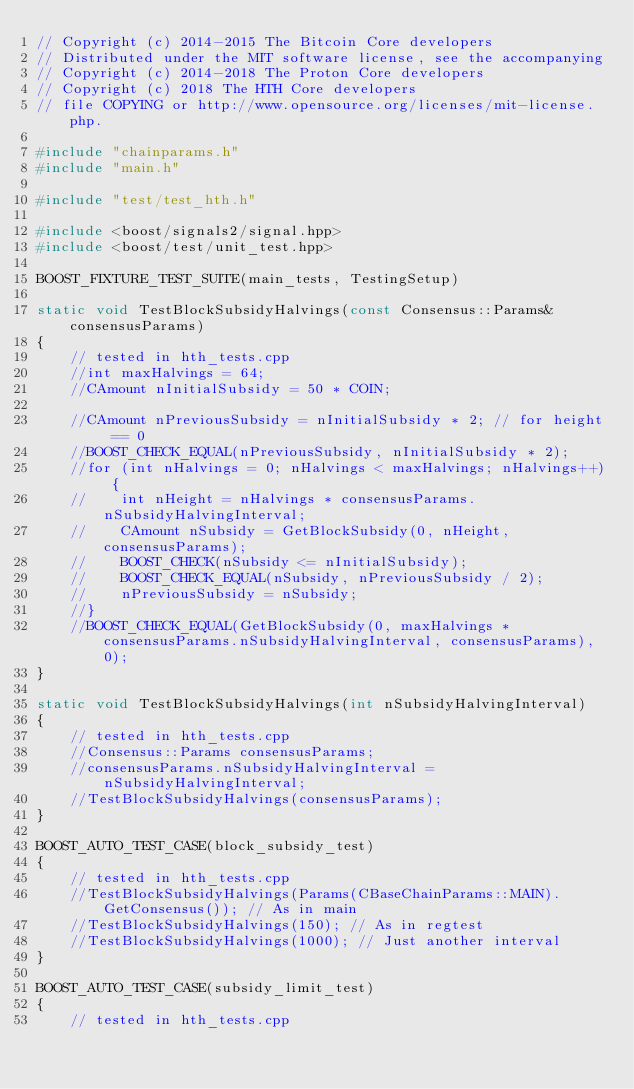Convert code to text. <code><loc_0><loc_0><loc_500><loc_500><_C++_>// Copyright (c) 2014-2015 The Bitcoin Core developers
// Distributed under the MIT software license, see the accompanying
// Copyright (c) 2014-2018 The Proton Core developers
// Copyright (c) 2018 The HTH Core developers
// file COPYING or http://www.opensource.org/licenses/mit-license.php.

#include "chainparams.h"
#include "main.h"

#include "test/test_hth.h"

#include <boost/signals2/signal.hpp>
#include <boost/test/unit_test.hpp>

BOOST_FIXTURE_TEST_SUITE(main_tests, TestingSetup)

static void TestBlockSubsidyHalvings(const Consensus::Params& consensusParams)
{
    // tested in hth_tests.cpp
    //int maxHalvings = 64;
    //CAmount nInitialSubsidy = 50 * COIN;

    //CAmount nPreviousSubsidy = nInitialSubsidy * 2; // for height == 0
    //BOOST_CHECK_EQUAL(nPreviousSubsidy, nInitialSubsidy * 2);
    //for (int nHalvings = 0; nHalvings < maxHalvings; nHalvings++) {
    //    int nHeight = nHalvings * consensusParams.nSubsidyHalvingInterval;
    //    CAmount nSubsidy = GetBlockSubsidy(0, nHeight, consensusParams);
    //    BOOST_CHECK(nSubsidy <= nInitialSubsidy);
    //    BOOST_CHECK_EQUAL(nSubsidy, nPreviousSubsidy / 2);
    //    nPreviousSubsidy = nSubsidy;
    //}
    //BOOST_CHECK_EQUAL(GetBlockSubsidy(0, maxHalvings * consensusParams.nSubsidyHalvingInterval, consensusParams), 0);
}

static void TestBlockSubsidyHalvings(int nSubsidyHalvingInterval)
{
    // tested in hth_tests.cpp
    //Consensus::Params consensusParams;
    //consensusParams.nSubsidyHalvingInterval = nSubsidyHalvingInterval;
    //TestBlockSubsidyHalvings(consensusParams);
}

BOOST_AUTO_TEST_CASE(block_subsidy_test)
{
    // tested in hth_tests.cpp
    //TestBlockSubsidyHalvings(Params(CBaseChainParams::MAIN).GetConsensus()); // As in main
    //TestBlockSubsidyHalvings(150); // As in regtest
    //TestBlockSubsidyHalvings(1000); // Just another interval
}

BOOST_AUTO_TEST_CASE(subsidy_limit_test)
{
    // tested in hth_tests.cpp</code> 